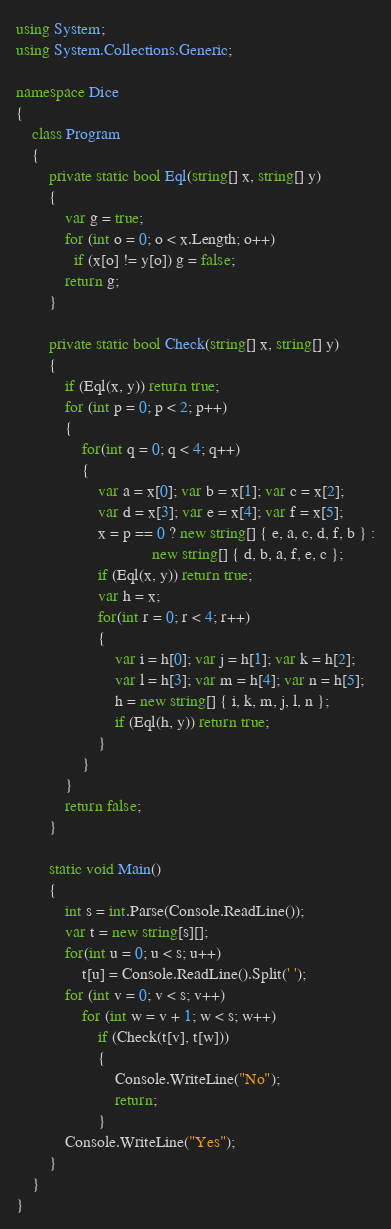Convert code to text. <code><loc_0><loc_0><loc_500><loc_500><_C#_>using System;
using System.Collections.Generic;

namespace Dice
{
    class Program
    {
        private static bool Eql(string[] x, string[] y)
        {
            var g = true;
            for (int o = 0; o < x.Length; o++)
              if (x[o] != y[o]) g = false;
            return g;
        }

        private static bool Check(string[] x, string[] y)
        {
            if (Eql(x, y)) return true;
            for (int p = 0; p < 2; p++)
            {
                for(int q = 0; q < 4; q++)
                {
                    var a = x[0]; var b = x[1]; var c = x[2];
                    var d = x[3]; var e = x[4]; var f = x[5];
                    x = p == 0 ? new string[] { e, a, c, d, f, b } :
                                 new string[] { d, b, a, f, e, c };
                    if (Eql(x, y)) return true;
                    var h = x;
                    for(int r = 0; r < 4; r++)
                    {
                        var i = h[0]; var j = h[1]; var k = h[2];
                        var l = h[3]; var m = h[4]; var n = h[5];
                        h = new string[] { i, k, m, j, l, n };
                        if (Eql(h, y)) return true;
                    }
                }
            }
            return false;
        }

        static void Main()
        {
            int s = int.Parse(Console.ReadLine());
            var t = new string[s][];
            for(int u = 0; u < s; u++)
                t[u] = Console.ReadLine().Split(' ');
            for (int v = 0; v < s; v++)
                for (int w = v + 1; w < s; w++)
                    if (Check(t[v], t[w]))
                    {
                        Console.WriteLine("No");
                        return;
                    }
            Console.WriteLine("Yes");
        }
    }
}</code> 